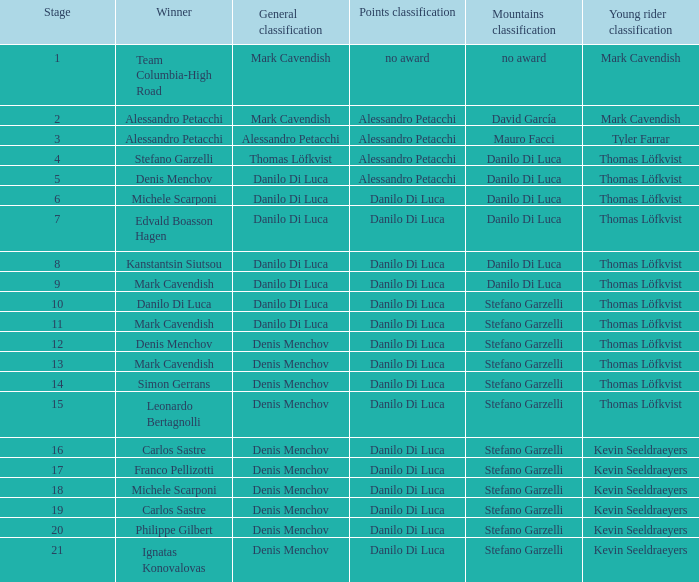When thomas löfkvist possesses the young rider classification and alessandro petacchi secures the points classification, who are the general classifications? Thomas Löfkvist, Danilo Di Luca. 